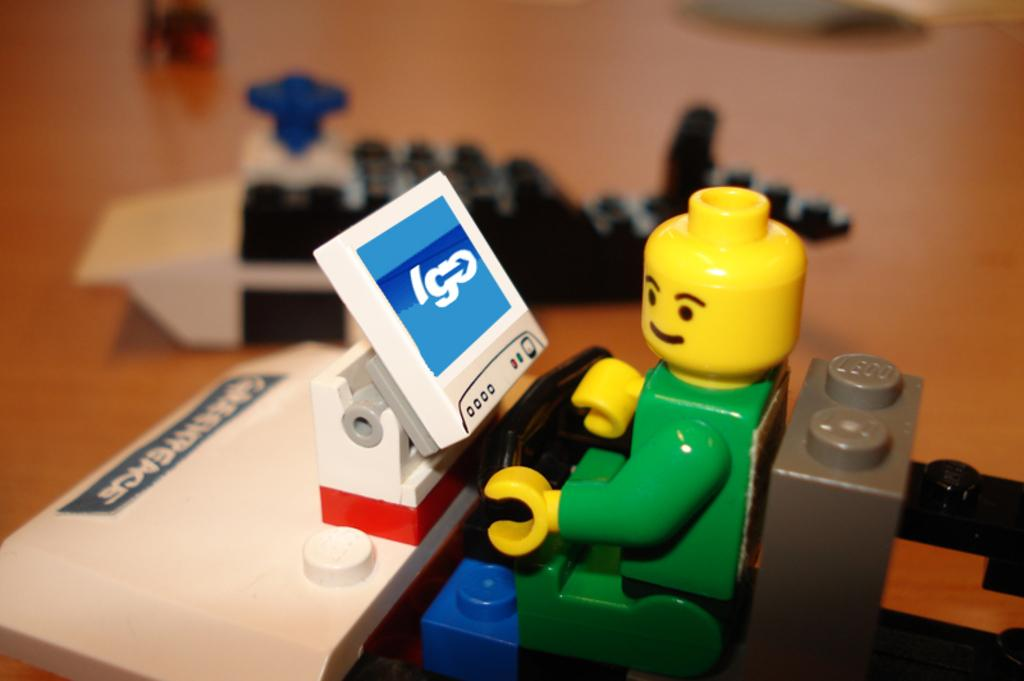What is present in the image? There is a toy in the image. Can you describe anything else visible in the image? There is another toy visible in the background of the image. What type of surface are the toys placed on? The toys are on a wooden surface. Are there any goldfish swimming in the zoo in the image? There is no zoo or goldfish present in the image; it features two toys on a wooden surface. 